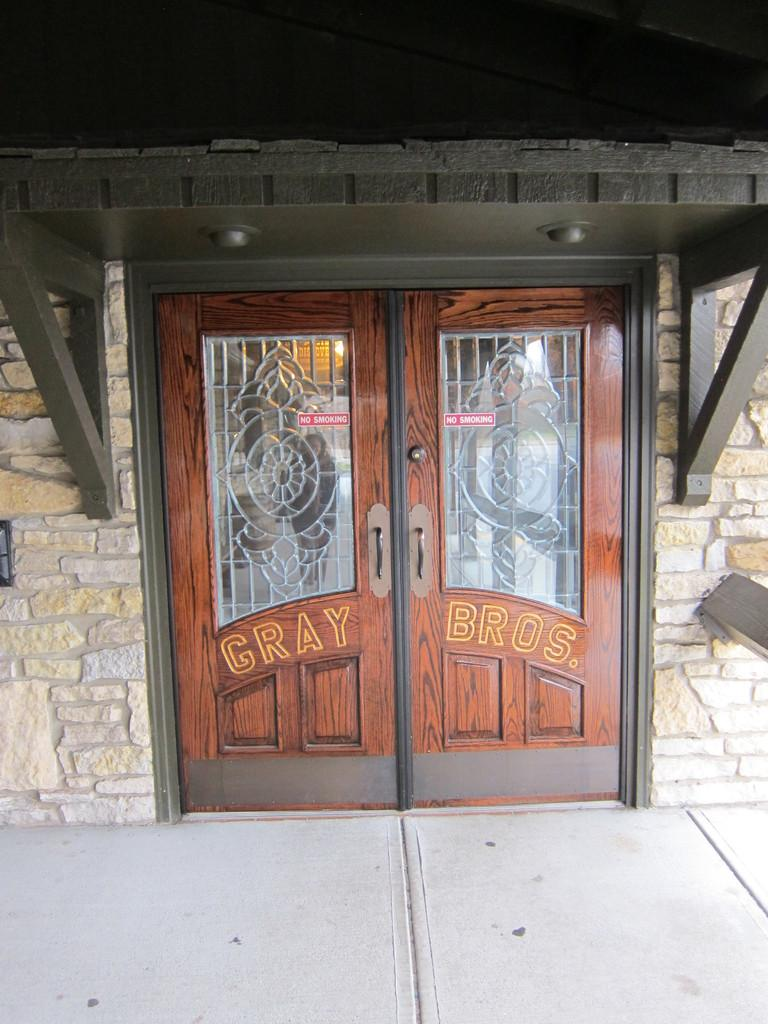What type of architectural feature can be seen in the image? There are doors in the image. What is written on the doors? Something is written on the doors. What surrounds the doors in the image? There are walls near the doors. What can be found on the walls in the image? There are wooden stands on the walls. Can you see a woman helping a rabbit in the image? There is no woman or rabbit present in the image. 